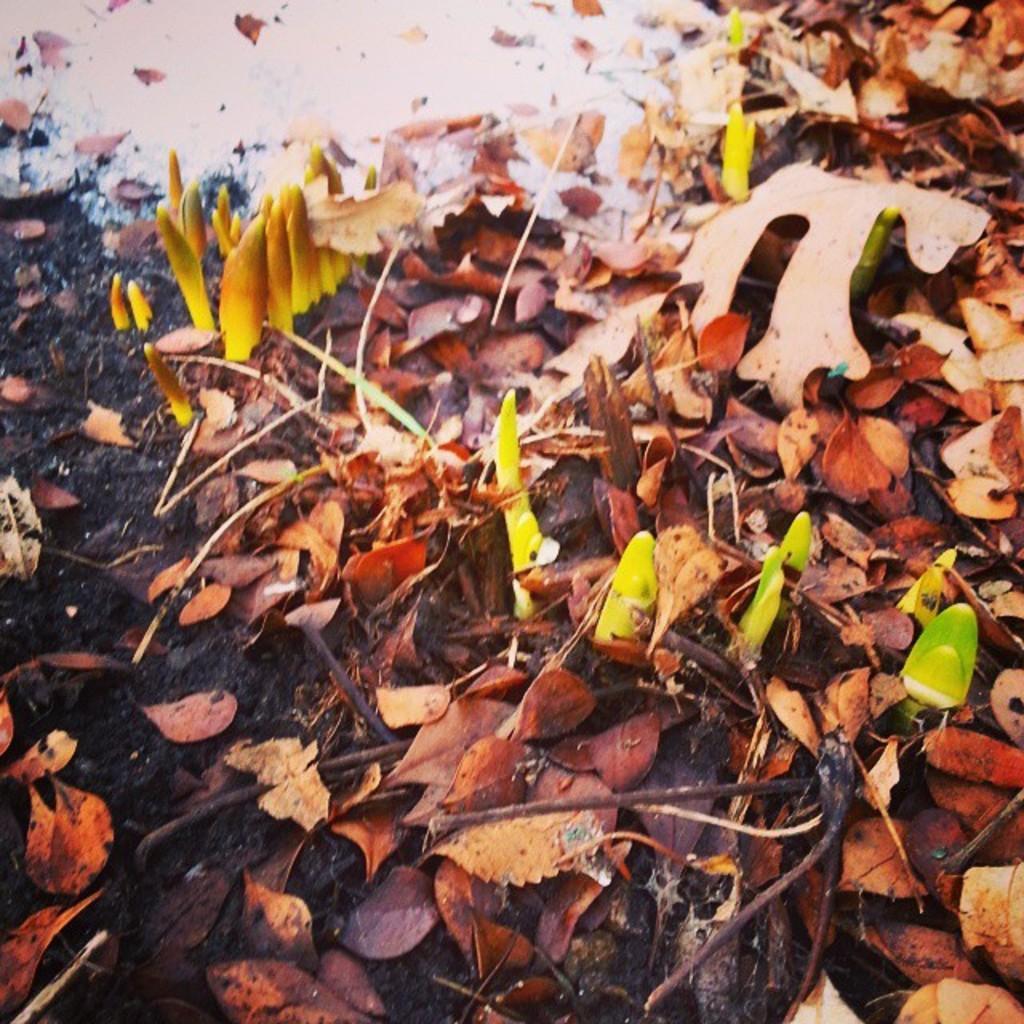How would you summarize this image in a sentence or two? The picture consists of dry leaves, soil, twigs and small plants. At the top there is a white color substance. 